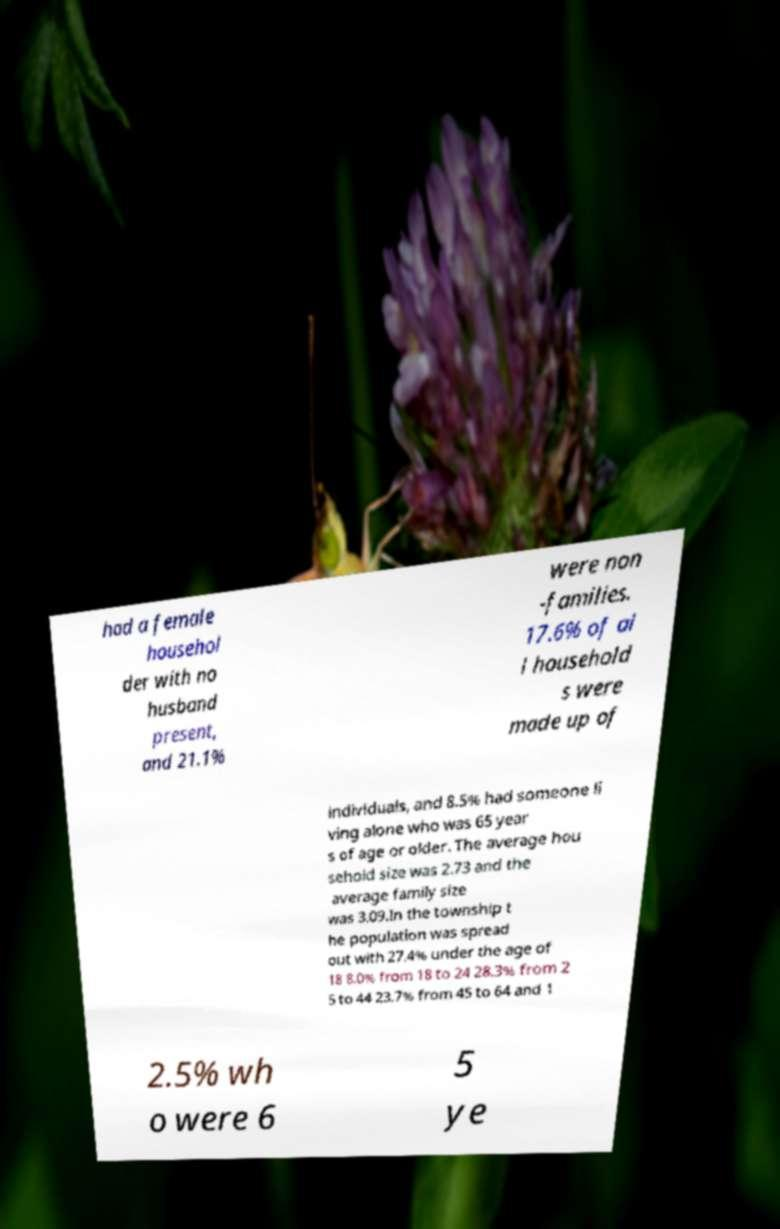I need the written content from this picture converted into text. Can you do that? had a female househol der with no husband present, and 21.1% were non -families. 17.6% of al l household s were made up of individuals, and 8.5% had someone li ving alone who was 65 year s of age or older. The average hou sehold size was 2.73 and the average family size was 3.09.In the township t he population was spread out with 27.4% under the age of 18 8.0% from 18 to 24 28.3% from 2 5 to 44 23.7% from 45 to 64 and 1 2.5% wh o were 6 5 ye 